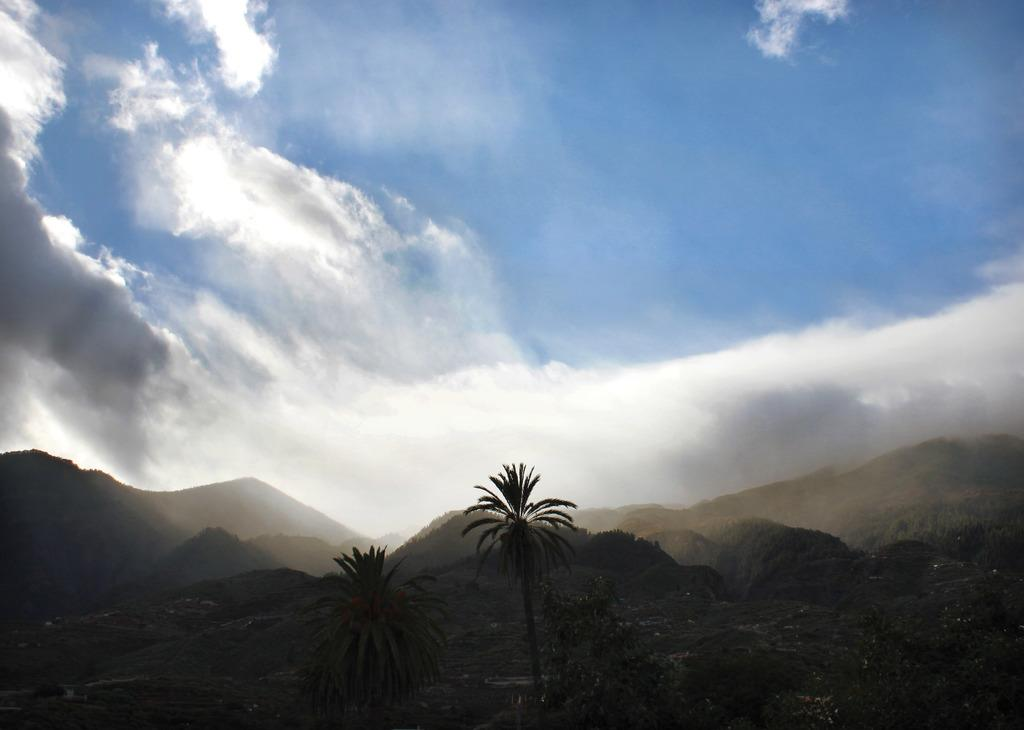Where was the image taken? The image was clicked outside the city. What can be seen in the foreground of the image? There are plants, trees, and hills in the foreground of the image. What is visible in the background of the image? The sky is visible in the background of the image. What is the condition of the sky in the image? The sky is full of clouds in the image. Can you see a window in the image? There is no window present in the image; it is an outdoor scene with plants, trees, hills, and a cloudy sky. Is there a church visible in the image? There is no church present in the image; it features an outdoor landscape with plants, trees, hills, and a cloudy sky. 